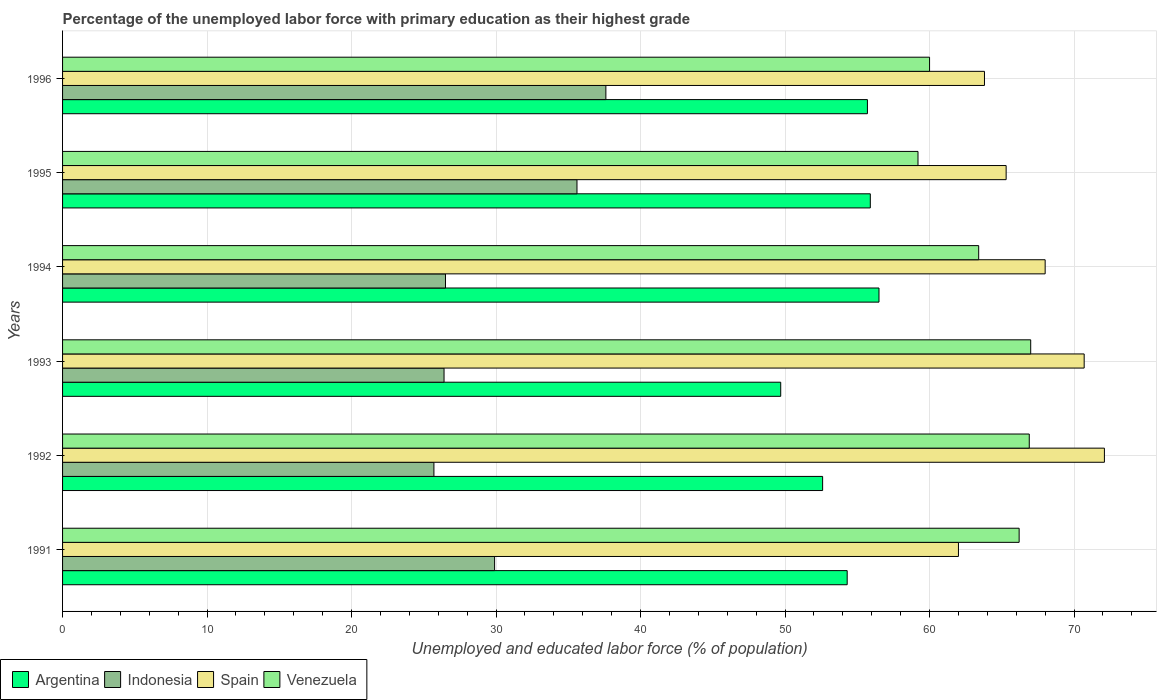How many groups of bars are there?
Give a very brief answer. 6. How many bars are there on the 3rd tick from the top?
Your response must be concise. 4. What is the label of the 6th group of bars from the top?
Offer a very short reply. 1991. In how many cases, is the number of bars for a given year not equal to the number of legend labels?
Your response must be concise. 0. What is the percentage of the unemployed labor force with primary education in Indonesia in 1996?
Keep it short and to the point. 37.6. Across all years, what is the maximum percentage of the unemployed labor force with primary education in Argentina?
Your answer should be very brief. 56.5. Across all years, what is the minimum percentage of the unemployed labor force with primary education in Spain?
Ensure brevity in your answer.  62. In which year was the percentage of the unemployed labor force with primary education in Argentina minimum?
Your answer should be compact. 1993. What is the total percentage of the unemployed labor force with primary education in Spain in the graph?
Provide a succinct answer. 401.9. What is the difference between the percentage of the unemployed labor force with primary education in Venezuela in 1991 and that in 1992?
Your answer should be compact. -0.7. What is the difference between the percentage of the unemployed labor force with primary education in Indonesia in 1992 and the percentage of the unemployed labor force with primary education in Spain in 1995?
Your answer should be compact. -39.6. What is the average percentage of the unemployed labor force with primary education in Indonesia per year?
Your response must be concise. 30.28. In the year 1991, what is the difference between the percentage of the unemployed labor force with primary education in Spain and percentage of the unemployed labor force with primary education in Argentina?
Offer a very short reply. 7.7. In how many years, is the percentage of the unemployed labor force with primary education in Spain greater than 70 %?
Offer a very short reply. 2. What is the ratio of the percentage of the unemployed labor force with primary education in Spain in 1991 to that in 1993?
Provide a short and direct response. 0.88. Is the percentage of the unemployed labor force with primary education in Spain in 1991 less than that in 1992?
Ensure brevity in your answer.  Yes. Is the difference between the percentage of the unemployed labor force with primary education in Spain in 1995 and 1996 greater than the difference between the percentage of the unemployed labor force with primary education in Argentina in 1995 and 1996?
Your answer should be compact. Yes. What is the difference between the highest and the second highest percentage of the unemployed labor force with primary education in Venezuela?
Your answer should be compact. 0.1. What is the difference between the highest and the lowest percentage of the unemployed labor force with primary education in Spain?
Make the answer very short. 10.1. Is it the case that in every year, the sum of the percentage of the unemployed labor force with primary education in Indonesia and percentage of the unemployed labor force with primary education in Spain is greater than the sum of percentage of the unemployed labor force with primary education in Argentina and percentage of the unemployed labor force with primary education in Venezuela?
Your answer should be very brief. No. What does the 3rd bar from the top in 1992 represents?
Offer a very short reply. Indonesia. What does the 4th bar from the bottom in 1992 represents?
Keep it short and to the point. Venezuela. Is it the case that in every year, the sum of the percentage of the unemployed labor force with primary education in Argentina and percentage of the unemployed labor force with primary education in Spain is greater than the percentage of the unemployed labor force with primary education in Indonesia?
Provide a succinct answer. Yes. How many bars are there?
Your response must be concise. 24. Are all the bars in the graph horizontal?
Your response must be concise. Yes. Are the values on the major ticks of X-axis written in scientific E-notation?
Your answer should be compact. No. Does the graph contain any zero values?
Offer a terse response. No. What is the title of the graph?
Your answer should be compact. Percentage of the unemployed labor force with primary education as their highest grade. What is the label or title of the X-axis?
Offer a terse response. Unemployed and educated labor force (% of population). What is the Unemployed and educated labor force (% of population) in Argentina in 1991?
Your answer should be very brief. 54.3. What is the Unemployed and educated labor force (% of population) of Indonesia in 1991?
Offer a very short reply. 29.9. What is the Unemployed and educated labor force (% of population) of Venezuela in 1991?
Your response must be concise. 66.2. What is the Unemployed and educated labor force (% of population) in Argentina in 1992?
Ensure brevity in your answer.  52.6. What is the Unemployed and educated labor force (% of population) of Indonesia in 1992?
Provide a succinct answer. 25.7. What is the Unemployed and educated labor force (% of population) of Spain in 1992?
Your answer should be compact. 72.1. What is the Unemployed and educated labor force (% of population) of Venezuela in 1992?
Give a very brief answer. 66.9. What is the Unemployed and educated labor force (% of population) in Argentina in 1993?
Your answer should be very brief. 49.7. What is the Unemployed and educated labor force (% of population) in Indonesia in 1993?
Give a very brief answer. 26.4. What is the Unemployed and educated labor force (% of population) of Spain in 1993?
Keep it short and to the point. 70.7. What is the Unemployed and educated labor force (% of population) of Venezuela in 1993?
Provide a succinct answer. 67. What is the Unemployed and educated labor force (% of population) in Argentina in 1994?
Keep it short and to the point. 56.5. What is the Unemployed and educated labor force (% of population) in Venezuela in 1994?
Offer a terse response. 63.4. What is the Unemployed and educated labor force (% of population) of Argentina in 1995?
Your answer should be very brief. 55.9. What is the Unemployed and educated labor force (% of population) of Indonesia in 1995?
Your answer should be very brief. 35.6. What is the Unemployed and educated labor force (% of population) in Spain in 1995?
Ensure brevity in your answer.  65.3. What is the Unemployed and educated labor force (% of population) of Venezuela in 1995?
Offer a very short reply. 59.2. What is the Unemployed and educated labor force (% of population) in Argentina in 1996?
Make the answer very short. 55.7. What is the Unemployed and educated labor force (% of population) of Indonesia in 1996?
Your answer should be very brief. 37.6. What is the Unemployed and educated labor force (% of population) in Spain in 1996?
Provide a short and direct response. 63.8. What is the Unemployed and educated labor force (% of population) in Venezuela in 1996?
Give a very brief answer. 60. Across all years, what is the maximum Unemployed and educated labor force (% of population) of Argentina?
Your answer should be compact. 56.5. Across all years, what is the maximum Unemployed and educated labor force (% of population) in Indonesia?
Provide a succinct answer. 37.6. Across all years, what is the maximum Unemployed and educated labor force (% of population) of Spain?
Keep it short and to the point. 72.1. Across all years, what is the maximum Unemployed and educated labor force (% of population) of Venezuela?
Make the answer very short. 67. Across all years, what is the minimum Unemployed and educated labor force (% of population) of Argentina?
Keep it short and to the point. 49.7. Across all years, what is the minimum Unemployed and educated labor force (% of population) of Indonesia?
Offer a terse response. 25.7. Across all years, what is the minimum Unemployed and educated labor force (% of population) in Venezuela?
Ensure brevity in your answer.  59.2. What is the total Unemployed and educated labor force (% of population) of Argentina in the graph?
Give a very brief answer. 324.7. What is the total Unemployed and educated labor force (% of population) in Indonesia in the graph?
Offer a terse response. 181.7. What is the total Unemployed and educated labor force (% of population) in Spain in the graph?
Your answer should be compact. 401.9. What is the total Unemployed and educated labor force (% of population) of Venezuela in the graph?
Keep it short and to the point. 382.7. What is the difference between the Unemployed and educated labor force (% of population) of Argentina in 1991 and that in 1992?
Your answer should be compact. 1.7. What is the difference between the Unemployed and educated labor force (% of population) of Spain in 1991 and that in 1993?
Give a very brief answer. -8.7. What is the difference between the Unemployed and educated labor force (% of population) of Venezuela in 1991 and that in 1993?
Give a very brief answer. -0.8. What is the difference between the Unemployed and educated labor force (% of population) in Spain in 1991 and that in 1994?
Provide a short and direct response. -6. What is the difference between the Unemployed and educated labor force (% of population) of Venezuela in 1991 and that in 1994?
Give a very brief answer. 2.8. What is the difference between the Unemployed and educated labor force (% of population) in Argentina in 1991 and that in 1995?
Provide a short and direct response. -1.6. What is the difference between the Unemployed and educated labor force (% of population) in Spain in 1991 and that in 1995?
Your response must be concise. -3.3. What is the difference between the Unemployed and educated labor force (% of population) of Spain in 1991 and that in 1996?
Offer a very short reply. -1.8. What is the difference between the Unemployed and educated labor force (% of population) in Venezuela in 1991 and that in 1996?
Ensure brevity in your answer.  6.2. What is the difference between the Unemployed and educated labor force (% of population) in Indonesia in 1992 and that in 1993?
Make the answer very short. -0.7. What is the difference between the Unemployed and educated labor force (% of population) in Spain in 1992 and that in 1993?
Your answer should be very brief. 1.4. What is the difference between the Unemployed and educated labor force (% of population) of Venezuela in 1992 and that in 1993?
Your answer should be compact. -0.1. What is the difference between the Unemployed and educated labor force (% of population) in Indonesia in 1992 and that in 1994?
Provide a succinct answer. -0.8. What is the difference between the Unemployed and educated labor force (% of population) of Spain in 1992 and that in 1994?
Make the answer very short. 4.1. What is the difference between the Unemployed and educated labor force (% of population) in Venezuela in 1992 and that in 1994?
Offer a very short reply. 3.5. What is the difference between the Unemployed and educated labor force (% of population) in Argentina in 1992 and that in 1995?
Your answer should be compact. -3.3. What is the difference between the Unemployed and educated labor force (% of population) in Indonesia in 1992 and that in 1995?
Make the answer very short. -9.9. What is the difference between the Unemployed and educated labor force (% of population) in Argentina in 1992 and that in 1996?
Your answer should be very brief. -3.1. What is the difference between the Unemployed and educated labor force (% of population) in Venezuela in 1992 and that in 1996?
Give a very brief answer. 6.9. What is the difference between the Unemployed and educated labor force (% of population) of Argentina in 1993 and that in 1994?
Your response must be concise. -6.8. What is the difference between the Unemployed and educated labor force (% of population) in Indonesia in 1993 and that in 1994?
Provide a succinct answer. -0.1. What is the difference between the Unemployed and educated labor force (% of population) of Spain in 1993 and that in 1994?
Your answer should be very brief. 2.7. What is the difference between the Unemployed and educated labor force (% of population) of Spain in 1993 and that in 1995?
Offer a terse response. 5.4. What is the difference between the Unemployed and educated labor force (% of population) in Indonesia in 1993 and that in 1996?
Make the answer very short. -11.2. What is the difference between the Unemployed and educated labor force (% of population) of Venezuela in 1993 and that in 1996?
Give a very brief answer. 7. What is the difference between the Unemployed and educated labor force (% of population) of Venezuela in 1994 and that in 1995?
Ensure brevity in your answer.  4.2. What is the difference between the Unemployed and educated labor force (% of population) in Argentina in 1994 and that in 1996?
Keep it short and to the point. 0.8. What is the difference between the Unemployed and educated labor force (% of population) of Venezuela in 1994 and that in 1996?
Keep it short and to the point. 3.4. What is the difference between the Unemployed and educated labor force (% of population) in Argentina in 1995 and that in 1996?
Keep it short and to the point. 0.2. What is the difference between the Unemployed and educated labor force (% of population) of Indonesia in 1995 and that in 1996?
Provide a succinct answer. -2. What is the difference between the Unemployed and educated labor force (% of population) in Spain in 1995 and that in 1996?
Keep it short and to the point. 1.5. What is the difference between the Unemployed and educated labor force (% of population) in Venezuela in 1995 and that in 1996?
Provide a succinct answer. -0.8. What is the difference between the Unemployed and educated labor force (% of population) of Argentina in 1991 and the Unemployed and educated labor force (% of population) of Indonesia in 1992?
Give a very brief answer. 28.6. What is the difference between the Unemployed and educated labor force (% of population) in Argentina in 1991 and the Unemployed and educated labor force (% of population) in Spain in 1992?
Provide a short and direct response. -17.8. What is the difference between the Unemployed and educated labor force (% of population) of Indonesia in 1991 and the Unemployed and educated labor force (% of population) of Spain in 1992?
Make the answer very short. -42.2. What is the difference between the Unemployed and educated labor force (% of population) of Indonesia in 1991 and the Unemployed and educated labor force (% of population) of Venezuela in 1992?
Give a very brief answer. -37. What is the difference between the Unemployed and educated labor force (% of population) in Spain in 1991 and the Unemployed and educated labor force (% of population) in Venezuela in 1992?
Provide a short and direct response. -4.9. What is the difference between the Unemployed and educated labor force (% of population) of Argentina in 1991 and the Unemployed and educated labor force (% of population) of Indonesia in 1993?
Give a very brief answer. 27.9. What is the difference between the Unemployed and educated labor force (% of population) in Argentina in 1991 and the Unemployed and educated labor force (% of population) in Spain in 1993?
Provide a short and direct response. -16.4. What is the difference between the Unemployed and educated labor force (% of population) in Indonesia in 1991 and the Unemployed and educated labor force (% of population) in Spain in 1993?
Make the answer very short. -40.8. What is the difference between the Unemployed and educated labor force (% of population) of Indonesia in 1991 and the Unemployed and educated labor force (% of population) of Venezuela in 1993?
Give a very brief answer. -37.1. What is the difference between the Unemployed and educated labor force (% of population) in Spain in 1991 and the Unemployed and educated labor force (% of population) in Venezuela in 1993?
Your response must be concise. -5. What is the difference between the Unemployed and educated labor force (% of population) of Argentina in 1991 and the Unemployed and educated labor force (% of population) of Indonesia in 1994?
Your answer should be compact. 27.8. What is the difference between the Unemployed and educated labor force (% of population) in Argentina in 1991 and the Unemployed and educated labor force (% of population) in Spain in 1994?
Ensure brevity in your answer.  -13.7. What is the difference between the Unemployed and educated labor force (% of population) of Argentina in 1991 and the Unemployed and educated labor force (% of population) of Venezuela in 1994?
Your response must be concise. -9.1. What is the difference between the Unemployed and educated labor force (% of population) of Indonesia in 1991 and the Unemployed and educated labor force (% of population) of Spain in 1994?
Give a very brief answer. -38.1. What is the difference between the Unemployed and educated labor force (% of population) of Indonesia in 1991 and the Unemployed and educated labor force (% of population) of Venezuela in 1994?
Offer a terse response. -33.5. What is the difference between the Unemployed and educated labor force (% of population) of Argentina in 1991 and the Unemployed and educated labor force (% of population) of Indonesia in 1995?
Your answer should be compact. 18.7. What is the difference between the Unemployed and educated labor force (% of population) of Argentina in 1991 and the Unemployed and educated labor force (% of population) of Spain in 1995?
Provide a short and direct response. -11. What is the difference between the Unemployed and educated labor force (% of population) of Indonesia in 1991 and the Unemployed and educated labor force (% of population) of Spain in 1995?
Provide a short and direct response. -35.4. What is the difference between the Unemployed and educated labor force (% of population) of Indonesia in 1991 and the Unemployed and educated labor force (% of population) of Venezuela in 1995?
Your response must be concise. -29.3. What is the difference between the Unemployed and educated labor force (% of population) in Spain in 1991 and the Unemployed and educated labor force (% of population) in Venezuela in 1995?
Your response must be concise. 2.8. What is the difference between the Unemployed and educated labor force (% of population) in Argentina in 1991 and the Unemployed and educated labor force (% of population) in Indonesia in 1996?
Offer a very short reply. 16.7. What is the difference between the Unemployed and educated labor force (% of population) in Indonesia in 1991 and the Unemployed and educated labor force (% of population) in Spain in 1996?
Provide a short and direct response. -33.9. What is the difference between the Unemployed and educated labor force (% of population) of Indonesia in 1991 and the Unemployed and educated labor force (% of population) of Venezuela in 1996?
Give a very brief answer. -30.1. What is the difference between the Unemployed and educated labor force (% of population) in Spain in 1991 and the Unemployed and educated labor force (% of population) in Venezuela in 1996?
Offer a very short reply. 2. What is the difference between the Unemployed and educated labor force (% of population) in Argentina in 1992 and the Unemployed and educated labor force (% of population) in Indonesia in 1993?
Your response must be concise. 26.2. What is the difference between the Unemployed and educated labor force (% of population) of Argentina in 1992 and the Unemployed and educated labor force (% of population) of Spain in 1993?
Your response must be concise. -18.1. What is the difference between the Unemployed and educated labor force (% of population) in Argentina in 1992 and the Unemployed and educated labor force (% of population) in Venezuela in 1993?
Your response must be concise. -14.4. What is the difference between the Unemployed and educated labor force (% of population) in Indonesia in 1992 and the Unemployed and educated labor force (% of population) in Spain in 1993?
Give a very brief answer. -45. What is the difference between the Unemployed and educated labor force (% of population) of Indonesia in 1992 and the Unemployed and educated labor force (% of population) of Venezuela in 1993?
Your response must be concise. -41.3. What is the difference between the Unemployed and educated labor force (% of population) of Argentina in 1992 and the Unemployed and educated labor force (% of population) of Indonesia in 1994?
Your response must be concise. 26.1. What is the difference between the Unemployed and educated labor force (% of population) of Argentina in 1992 and the Unemployed and educated labor force (% of population) of Spain in 1994?
Make the answer very short. -15.4. What is the difference between the Unemployed and educated labor force (% of population) of Argentina in 1992 and the Unemployed and educated labor force (% of population) of Venezuela in 1994?
Make the answer very short. -10.8. What is the difference between the Unemployed and educated labor force (% of population) of Indonesia in 1992 and the Unemployed and educated labor force (% of population) of Spain in 1994?
Give a very brief answer. -42.3. What is the difference between the Unemployed and educated labor force (% of population) of Indonesia in 1992 and the Unemployed and educated labor force (% of population) of Venezuela in 1994?
Provide a short and direct response. -37.7. What is the difference between the Unemployed and educated labor force (% of population) in Argentina in 1992 and the Unemployed and educated labor force (% of population) in Indonesia in 1995?
Ensure brevity in your answer.  17. What is the difference between the Unemployed and educated labor force (% of population) of Argentina in 1992 and the Unemployed and educated labor force (% of population) of Spain in 1995?
Provide a succinct answer. -12.7. What is the difference between the Unemployed and educated labor force (% of population) in Argentina in 1992 and the Unemployed and educated labor force (% of population) in Venezuela in 1995?
Your answer should be compact. -6.6. What is the difference between the Unemployed and educated labor force (% of population) in Indonesia in 1992 and the Unemployed and educated labor force (% of population) in Spain in 1995?
Offer a terse response. -39.6. What is the difference between the Unemployed and educated labor force (% of population) in Indonesia in 1992 and the Unemployed and educated labor force (% of population) in Venezuela in 1995?
Ensure brevity in your answer.  -33.5. What is the difference between the Unemployed and educated labor force (% of population) of Spain in 1992 and the Unemployed and educated labor force (% of population) of Venezuela in 1995?
Offer a very short reply. 12.9. What is the difference between the Unemployed and educated labor force (% of population) of Argentina in 1992 and the Unemployed and educated labor force (% of population) of Indonesia in 1996?
Ensure brevity in your answer.  15. What is the difference between the Unemployed and educated labor force (% of population) of Argentina in 1992 and the Unemployed and educated labor force (% of population) of Spain in 1996?
Give a very brief answer. -11.2. What is the difference between the Unemployed and educated labor force (% of population) of Indonesia in 1992 and the Unemployed and educated labor force (% of population) of Spain in 1996?
Your answer should be compact. -38.1. What is the difference between the Unemployed and educated labor force (% of population) in Indonesia in 1992 and the Unemployed and educated labor force (% of population) in Venezuela in 1996?
Offer a very short reply. -34.3. What is the difference between the Unemployed and educated labor force (% of population) in Argentina in 1993 and the Unemployed and educated labor force (% of population) in Indonesia in 1994?
Give a very brief answer. 23.2. What is the difference between the Unemployed and educated labor force (% of population) of Argentina in 1993 and the Unemployed and educated labor force (% of population) of Spain in 1994?
Offer a very short reply. -18.3. What is the difference between the Unemployed and educated labor force (% of population) in Argentina in 1993 and the Unemployed and educated labor force (% of population) in Venezuela in 1994?
Provide a succinct answer. -13.7. What is the difference between the Unemployed and educated labor force (% of population) of Indonesia in 1993 and the Unemployed and educated labor force (% of population) of Spain in 1994?
Offer a very short reply. -41.6. What is the difference between the Unemployed and educated labor force (% of population) in Indonesia in 1993 and the Unemployed and educated labor force (% of population) in Venezuela in 1994?
Ensure brevity in your answer.  -37. What is the difference between the Unemployed and educated labor force (% of population) of Argentina in 1993 and the Unemployed and educated labor force (% of population) of Indonesia in 1995?
Provide a succinct answer. 14.1. What is the difference between the Unemployed and educated labor force (% of population) in Argentina in 1993 and the Unemployed and educated labor force (% of population) in Spain in 1995?
Offer a terse response. -15.6. What is the difference between the Unemployed and educated labor force (% of population) of Indonesia in 1993 and the Unemployed and educated labor force (% of population) of Spain in 1995?
Your answer should be compact. -38.9. What is the difference between the Unemployed and educated labor force (% of population) in Indonesia in 1993 and the Unemployed and educated labor force (% of population) in Venezuela in 1995?
Your answer should be very brief. -32.8. What is the difference between the Unemployed and educated labor force (% of population) in Argentina in 1993 and the Unemployed and educated labor force (% of population) in Indonesia in 1996?
Your response must be concise. 12.1. What is the difference between the Unemployed and educated labor force (% of population) of Argentina in 1993 and the Unemployed and educated labor force (% of population) of Spain in 1996?
Provide a short and direct response. -14.1. What is the difference between the Unemployed and educated labor force (% of population) of Indonesia in 1993 and the Unemployed and educated labor force (% of population) of Spain in 1996?
Offer a very short reply. -37.4. What is the difference between the Unemployed and educated labor force (% of population) of Indonesia in 1993 and the Unemployed and educated labor force (% of population) of Venezuela in 1996?
Make the answer very short. -33.6. What is the difference between the Unemployed and educated labor force (% of population) of Spain in 1993 and the Unemployed and educated labor force (% of population) of Venezuela in 1996?
Give a very brief answer. 10.7. What is the difference between the Unemployed and educated labor force (% of population) in Argentina in 1994 and the Unemployed and educated labor force (% of population) in Indonesia in 1995?
Keep it short and to the point. 20.9. What is the difference between the Unemployed and educated labor force (% of population) of Indonesia in 1994 and the Unemployed and educated labor force (% of population) of Spain in 1995?
Keep it short and to the point. -38.8. What is the difference between the Unemployed and educated labor force (% of population) of Indonesia in 1994 and the Unemployed and educated labor force (% of population) of Venezuela in 1995?
Provide a short and direct response. -32.7. What is the difference between the Unemployed and educated labor force (% of population) of Spain in 1994 and the Unemployed and educated labor force (% of population) of Venezuela in 1995?
Make the answer very short. 8.8. What is the difference between the Unemployed and educated labor force (% of population) of Argentina in 1994 and the Unemployed and educated labor force (% of population) of Indonesia in 1996?
Make the answer very short. 18.9. What is the difference between the Unemployed and educated labor force (% of population) of Argentina in 1994 and the Unemployed and educated labor force (% of population) of Spain in 1996?
Your answer should be compact. -7.3. What is the difference between the Unemployed and educated labor force (% of population) of Argentina in 1994 and the Unemployed and educated labor force (% of population) of Venezuela in 1996?
Offer a very short reply. -3.5. What is the difference between the Unemployed and educated labor force (% of population) in Indonesia in 1994 and the Unemployed and educated labor force (% of population) in Spain in 1996?
Your response must be concise. -37.3. What is the difference between the Unemployed and educated labor force (% of population) of Indonesia in 1994 and the Unemployed and educated labor force (% of population) of Venezuela in 1996?
Keep it short and to the point. -33.5. What is the difference between the Unemployed and educated labor force (% of population) of Spain in 1994 and the Unemployed and educated labor force (% of population) of Venezuela in 1996?
Your response must be concise. 8. What is the difference between the Unemployed and educated labor force (% of population) in Argentina in 1995 and the Unemployed and educated labor force (% of population) in Indonesia in 1996?
Keep it short and to the point. 18.3. What is the difference between the Unemployed and educated labor force (% of population) of Indonesia in 1995 and the Unemployed and educated labor force (% of population) of Spain in 1996?
Provide a short and direct response. -28.2. What is the difference between the Unemployed and educated labor force (% of population) of Indonesia in 1995 and the Unemployed and educated labor force (% of population) of Venezuela in 1996?
Your response must be concise. -24.4. What is the average Unemployed and educated labor force (% of population) of Argentina per year?
Give a very brief answer. 54.12. What is the average Unemployed and educated labor force (% of population) of Indonesia per year?
Keep it short and to the point. 30.28. What is the average Unemployed and educated labor force (% of population) in Spain per year?
Your answer should be compact. 66.98. What is the average Unemployed and educated labor force (% of population) in Venezuela per year?
Provide a succinct answer. 63.78. In the year 1991, what is the difference between the Unemployed and educated labor force (% of population) of Argentina and Unemployed and educated labor force (% of population) of Indonesia?
Give a very brief answer. 24.4. In the year 1991, what is the difference between the Unemployed and educated labor force (% of population) of Argentina and Unemployed and educated labor force (% of population) of Spain?
Keep it short and to the point. -7.7. In the year 1991, what is the difference between the Unemployed and educated labor force (% of population) of Argentina and Unemployed and educated labor force (% of population) of Venezuela?
Your answer should be very brief. -11.9. In the year 1991, what is the difference between the Unemployed and educated labor force (% of population) in Indonesia and Unemployed and educated labor force (% of population) in Spain?
Offer a terse response. -32.1. In the year 1991, what is the difference between the Unemployed and educated labor force (% of population) in Indonesia and Unemployed and educated labor force (% of population) in Venezuela?
Your answer should be very brief. -36.3. In the year 1992, what is the difference between the Unemployed and educated labor force (% of population) in Argentina and Unemployed and educated labor force (% of population) in Indonesia?
Make the answer very short. 26.9. In the year 1992, what is the difference between the Unemployed and educated labor force (% of population) of Argentina and Unemployed and educated labor force (% of population) of Spain?
Your answer should be compact. -19.5. In the year 1992, what is the difference between the Unemployed and educated labor force (% of population) in Argentina and Unemployed and educated labor force (% of population) in Venezuela?
Offer a terse response. -14.3. In the year 1992, what is the difference between the Unemployed and educated labor force (% of population) in Indonesia and Unemployed and educated labor force (% of population) in Spain?
Offer a very short reply. -46.4. In the year 1992, what is the difference between the Unemployed and educated labor force (% of population) of Indonesia and Unemployed and educated labor force (% of population) of Venezuela?
Provide a succinct answer. -41.2. In the year 1993, what is the difference between the Unemployed and educated labor force (% of population) of Argentina and Unemployed and educated labor force (% of population) of Indonesia?
Offer a very short reply. 23.3. In the year 1993, what is the difference between the Unemployed and educated labor force (% of population) in Argentina and Unemployed and educated labor force (% of population) in Venezuela?
Give a very brief answer. -17.3. In the year 1993, what is the difference between the Unemployed and educated labor force (% of population) of Indonesia and Unemployed and educated labor force (% of population) of Spain?
Your answer should be compact. -44.3. In the year 1993, what is the difference between the Unemployed and educated labor force (% of population) of Indonesia and Unemployed and educated labor force (% of population) of Venezuela?
Provide a short and direct response. -40.6. In the year 1994, what is the difference between the Unemployed and educated labor force (% of population) of Argentina and Unemployed and educated labor force (% of population) of Indonesia?
Offer a terse response. 30. In the year 1994, what is the difference between the Unemployed and educated labor force (% of population) in Indonesia and Unemployed and educated labor force (% of population) in Spain?
Keep it short and to the point. -41.5. In the year 1994, what is the difference between the Unemployed and educated labor force (% of population) in Indonesia and Unemployed and educated labor force (% of population) in Venezuela?
Offer a very short reply. -36.9. In the year 1994, what is the difference between the Unemployed and educated labor force (% of population) of Spain and Unemployed and educated labor force (% of population) of Venezuela?
Ensure brevity in your answer.  4.6. In the year 1995, what is the difference between the Unemployed and educated labor force (% of population) of Argentina and Unemployed and educated labor force (% of population) of Indonesia?
Your response must be concise. 20.3. In the year 1995, what is the difference between the Unemployed and educated labor force (% of population) of Argentina and Unemployed and educated labor force (% of population) of Spain?
Offer a terse response. -9.4. In the year 1995, what is the difference between the Unemployed and educated labor force (% of population) of Argentina and Unemployed and educated labor force (% of population) of Venezuela?
Your answer should be compact. -3.3. In the year 1995, what is the difference between the Unemployed and educated labor force (% of population) in Indonesia and Unemployed and educated labor force (% of population) in Spain?
Offer a very short reply. -29.7. In the year 1995, what is the difference between the Unemployed and educated labor force (% of population) in Indonesia and Unemployed and educated labor force (% of population) in Venezuela?
Your answer should be very brief. -23.6. In the year 1995, what is the difference between the Unemployed and educated labor force (% of population) of Spain and Unemployed and educated labor force (% of population) of Venezuela?
Provide a succinct answer. 6.1. In the year 1996, what is the difference between the Unemployed and educated labor force (% of population) in Argentina and Unemployed and educated labor force (% of population) in Indonesia?
Provide a succinct answer. 18.1. In the year 1996, what is the difference between the Unemployed and educated labor force (% of population) in Argentina and Unemployed and educated labor force (% of population) in Spain?
Provide a short and direct response. -8.1. In the year 1996, what is the difference between the Unemployed and educated labor force (% of population) in Indonesia and Unemployed and educated labor force (% of population) in Spain?
Your answer should be very brief. -26.2. In the year 1996, what is the difference between the Unemployed and educated labor force (% of population) in Indonesia and Unemployed and educated labor force (% of population) in Venezuela?
Give a very brief answer. -22.4. In the year 1996, what is the difference between the Unemployed and educated labor force (% of population) in Spain and Unemployed and educated labor force (% of population) in Venezuela?
Your answer should be very brief. 3.8. What is the ratio of the Unemployed and educated labor force (% of population) in Argentina in 1991 to that in 1992?
Provide a short and direct response. 1.03. What is the ratio of the Unemployed and educated labor force (% of population) of Indonesia in 1991 to that in 1992?
Give a very brief answer. 1.16. What is the ratio of the Unemployed and educated labor force (% of population) of Spain in 1991 to that in 1992?
Offer a very short reply. 0.86. What is the ratio of the Unemployed and educated labor force (% of population) of Argentina in 1991 to that in 1993?
Your response must be concise. 1.09. What is the ratio of the Unemployed and educated labor force (% of population) in Indonesia in 1991 to that in 1993?
Offer a very short reply. 1.13. What is the ratio of the Unemployed and educated labor force (% of population) of Spain in 1991 to that in 1993?
Your answer should be very brief. 0.88. What is the ratio of the Unemployed and educated labor force (% of population) in Argentina in 1991 to that in 1994?
Ensure brevity in your answer.  0.96. What is the ratio of the Unemployed and educated labor force (% of population) in Indonesia in 1991 to that in 1994?
Ensure brevity in your answer.  1.13. What is the ratio of the Unemployed and educated labor force (% of population) of Spain in 1991 to that in 1994?
Provide a short and direct response. 0.91. What is the ratio of the Unemployed and educated labor force (% of population) of Venezuela in 1991 to that in 1994?
Offer a terse response. 1.04. What is the ratio of the Unemployed and educated labor force (% of population) in Argentina in 1991 to that in 1995?
Keep it short and to the point. 0.97. What is the ratio of the Unemployed and educated labor force (% of population) of Indonesia in 1991 to that in 1995?
Your answer should be compact. 0.84. What is the ratio of the Unemployed and educated labor force (% of population) in Spain in 1991 to that in 1995?
Provide a succinct answer. 0.95. What is the ratio of the Unemployed and educated labor force (% of population) of Venezuela in 1991 to that in 1995?
Your answer should be compact. 1.12. What is the ratio of the Unemployed and educated labor force (% of population) in Argentina in 1991 to that in 1996?
Provide a short and direct response. 0.97. What is the ratio of the Unemployed and educated labor force (% of population) in Indonesia in 1991 to that in 1996?
Give a very brief answer. 0.8. What is the ratio of the Unemployed and educated labor force (% of population) in Spain in 1991 to that in 1996?
Provide a short and direct response. 0.97. What is the ratio of the Unemployed and educated labor force (% of population) of Venezuela in 1991 to that in 1996?
Your answer should be very brief. 1.1. What is the ratio of the Unemployed and educated labor force (% of population) of Argentina in 1992 to that in 1993?
Your answer should be compact. 1.06. What is the ratio of the Unemployed and educated labor force (% of population) of Indonesia in 1992 to that in 1993?
Your answer should be very brief. 0.97. What is the ratio of the Unemployed and educated labor force (% of population) in Spain in 1992 to that in 1993?
Provide a succinct answer. 1.02. What is the ratio of the Unemployed and educated labor force (% of population) in Argentina in 1992 to that in 1994?
Provide a succinct answer. 0.93. What is the ratio of the Unemployed and educated labor force (% of population) of Indonesia in 1992 to that in 1994?
Keep it short and to the point. 0.97. What is the ratio of the Unemployed and educated labor force (% of population) of Spain in 1992 to that in 1994?
Ensure brevity in your answer.  1.06. What is the ratio of the Unemployed and educated labor force (% of population) in Venezuela in 1992 to that in 1994?
Provide a short and direct response. 1.06. What is the ratio of the Unemployed and educated labor force (% of population) in Argentina in 1992 to that in 1995?
Provide a short and direct response. 0.94. What is the ratio of the Unemployed and educated labor force (% of population) of Indonesia in 1992 to that in 1995?
Offer a very short reply. 0.72. What is the ratio of the Unemployed and educated labor force (% of population) of Spain in 1992 to that in 1995?
Provide a succinct answer. 1.1. What is the ratio of the Unemployed and educated labor force (% of population) in Venezuela in 1992 to that in 1995?
Offer a very short reply. 1.13. What is the ratio of the Unemployed and educated labor force (% of population) of Argentina in 1992 to that in 1996?
Your answer should be compact. 0.94. What is the ratio of the Unemployed and educated labor force (% of population) of Indonesia in 1992 to that in 1996?
Your response must be concise. 0.68. What is the ratio of the Unemployed and educated labor force (% of population) in Spain in 1992 to that in 1996?
Your response must be concise. 1.13. What is the ratio of the Unemployed and educated labor force (% of population) in Venezuela in 1992 to that in 1996?
Give a very brief answer. 1.11. What is the ratio of the Unemployed and educated labor force (% of population) of Argentina in 1993 to that in 1994?
Your response must be concise. 0.88. What is the ratio of the Unemployed and educated labor force (% of population) in Spain in 1993 to that in 1994?
Make the answer very short. 1.04. What is the ratio of the Unemployed and educated labor force (% of population) of Venezuela in 1993 to that in 1994?
Ensure brevity in your answer.  1.06. What is the ratio of the Unemployed and educated labor force (% of population) in Argentina in 1993 to that in 1995?
Ensure brevity in your answer.  0.89. What is the ratio of the Unemployed and educated labor force (% of population) in Indonesia in 1993 to that in 1995?
Provide a short and direct response. 0.74. What is the ratio of the Unemployed and educated labor force (% of population) of Spain in 1993 to that in 1995?
Keep it short and to the point. 1.08. What is the ratio of the Unemployed and educated labor force (% of population) of Venezuela in 1993 to that in 1995?
Your answer should be compact. 1.13. What is the ratio of the Unemployed and educated labor force (% of population) in Argentina in 1993 to that in 1996?
Your answer should be very brief. 0.89. What is the ratio of the Unemployed and educated labor force (% of population) in Indonesia in 1993 to that in 1996?
Make the answer very short. 0.7. What is the ratio of the Unemployed and educated labor force (% of population) in Spain in 1993 to that in 1996?
Your answer should be compact. 1.11. What is the ratio of the Unemployed and educated labor force (% of population) in Venezuela in 1993 to that in 1996?
Make the answer very short. 1.12. What is the ratio of the Unemployed and educated labor force (% of population) of Argentina in 1994 to that in 1995?
Your response must be concise. 1.01. What is the ratio of the Unemployed and educated labor force (% of population) of Indonesia in 1994 to that in 1995?
Your answer should be compact. 0.74. What is the ratio of the Unemployed and educated labor force (% of population) of Spain in 1994 to that in 1995?
Give a very brief answer. 1.04. What is the ratio of the Unemployed and educated labor force (% of population) in Venezuela in 1994 to that in 1995?
Your response must be concise. 1.07. What is the ratio of the Unemployed and educated labor force (% of population) of Argentina in 1994 to that in 1996?
Ensure brevity in your answer.  1.01. What is the ratio of the Unemployed and educated labor force (% of population) in Indonesia in 1994 to that in 1996?
Your answer should be very brief. 0.7. What is the ratio of the Unemployed and educated labor force (% of population) of Spain in 1994 to that in 1996?
Ensure brevity in your answer.  1.07. What is the ratio of the Unemployed and educated labor force (% of population) of Venezuela in 1994 to that in 1996?
Offer a terse response. 1.06. What is the ratio of the Unemployed and educated labor force (% of population) of Indonesia in 1995 to that in 1996?
Make the answer very short. 0.95. What is the ratio of the Unemployed and educated labor force (% of population) in Spain in 1995 to that in 1996?
Provide a succinct answer. 1.02. What is the ratio of the Unemployed and educated labor force (% of population) in Venezuela in 1995 to that in 1996?
Offer a terse response. 0.99. What is the difference between the highest and the second highest Unemployed and educated labor force (% of population) in Argentina?
Ensure brevity in your answer.  0.6. What is the difference between the highest and the second highest Unemployed and educated labor force (% of population) in Venezuela?
Ensure brevity in your answer.  0.1. What is the difference between the highest and the lowest Unemployed and educated labor force (% of population) in Argentina?
Provide a succinct answer. 6.8. What is the difference between the highest and the lowest Unemployed and educated labor force (% of population) of Indonesia?
Your response must be concise. 11.9. 